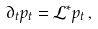<formula> <loc_0><loc_0><loc_500><loc_500>\partial _ { t } p _ { t } = \mathcal { L } ^ { * } p _ { t } \, ,</formula> 